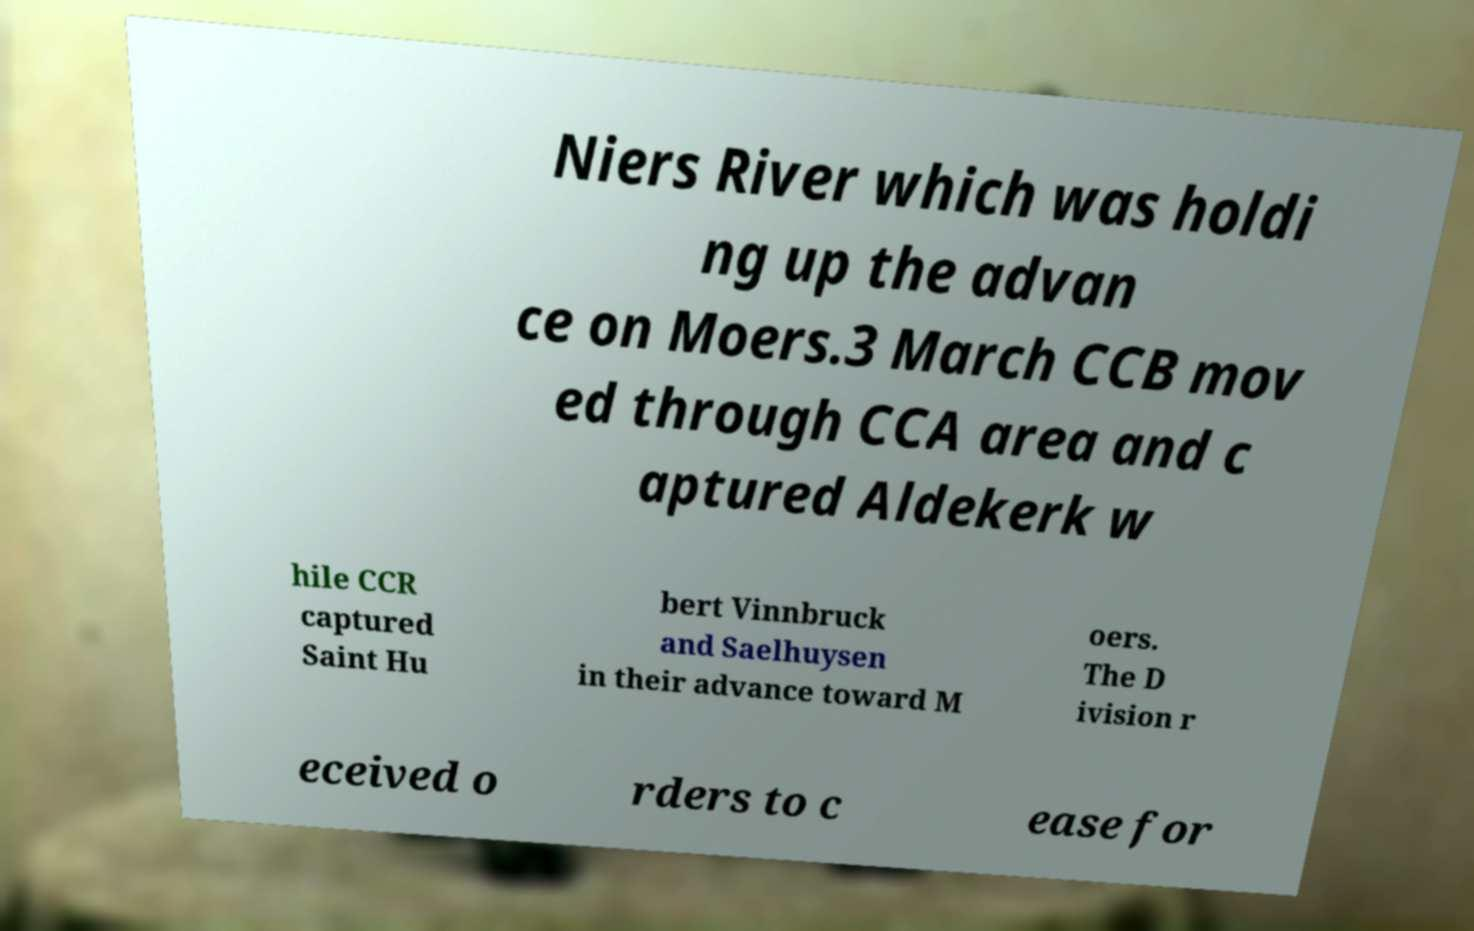Can you accurately transcribe the text from the provided image for me? Niers River which was holdi ng up the advan ce on Moers.3 March CCB mov ed through CCA area and c aptured Aldekerk w hile CCR captured Saint Hu bert Vinnbruck and Saelhuysen in their advance toward M oers. The D ivision r eceived o rders to c ease for 